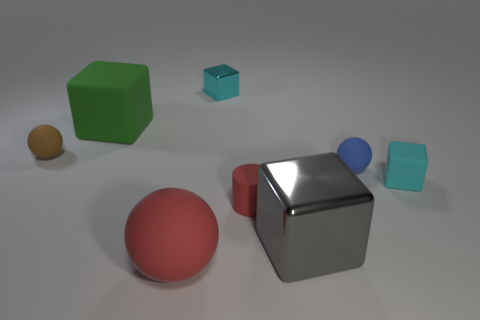There is a matte cube on the right side of the big sphere; is its color the same as the large ball?
Provide a succinct answer. No. Does the green cube have the same material as the cylinder?
Provide a short and direct response. Yes. Are there an equal number of cyan metal blocks in front of the small red cylinder and gray blocks in front of the big shiny object?
Make the answer very short. Yes. What is the material of the big green thing that is the same shape as the gray thing?
Ensure brevity in your answer.  Rubber. There is a red object on the right side of the cyan cube that is left of the tiny cyan thing in front of the big green matte thing; what shape is it?
Give a very brief answer. Cylinder. Is the number of tiny objects that are to the left of the blue thing greater than the number of blocks?
Offer a terse response. No. Does the cyan object to the right of the tiny blue ball have the same shape as the big metallic thing?
Your answer should be compact. Yes. What material is the cyan cube that is to the right of the small blue matte thing?
Your answer should be very brief. Rubber. How many other tiny rubber objects are the same shape as the small brown matte thing?
Your answer should be compact. 1. What is the material of the cyan cube that is in front of the tiny blue sphere that is behind the gray object?
Your response must be concise. Rubber. 